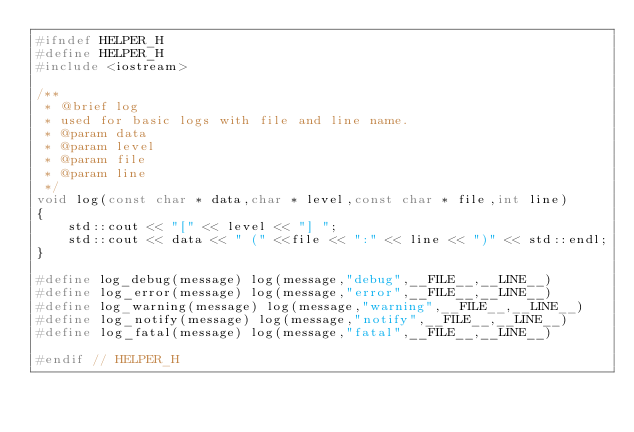<code> <loc_0><loc_0><loc_500><loc_500><_C_>#ifndef HELPER_H
#define HELPER_H
#include <iostream>

/**
 * @brief log
 * used for basic logs with file and line name.
 * @param data
 * @param level
 * @param file
 * @param line
 */
void log(const char * data,char * level,const char * file,int line)
{
    std::cout << "[" << level << "] ";
    std::cout << data << " (" <<file << ":" << line << ")" << std::endl;
}

#define log_debug(message) log(message,"debug",__FILE__,__LINE__)
#define log_error(message) log(message,"error",__FILE__,__LINE__)
#define log_warning(message) log(message,"warning",__FILE__,__LINE__)
#define log_notify(message) log(message,"notify",__FILE__,__LINE__)
#define log_fatal(message) log(message,"fatal",__FILE__,__LINE__)

#endif // HELPER_H
</code> 